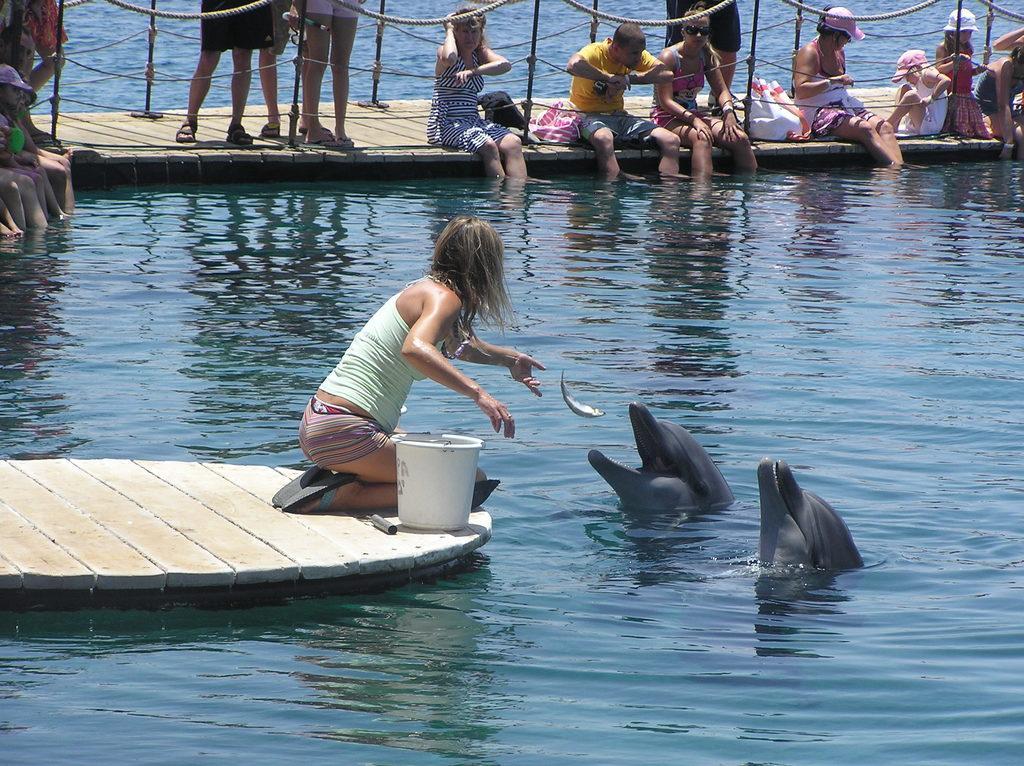In one or two sentences, can you explain what this image depicts? The picture consists of a water body. In the foreground of the picture there are dolphins, a woman feeding the dolphins with fish, a bucket and dock. At the top there is a dock, on the dock there are people, bags and railings. 